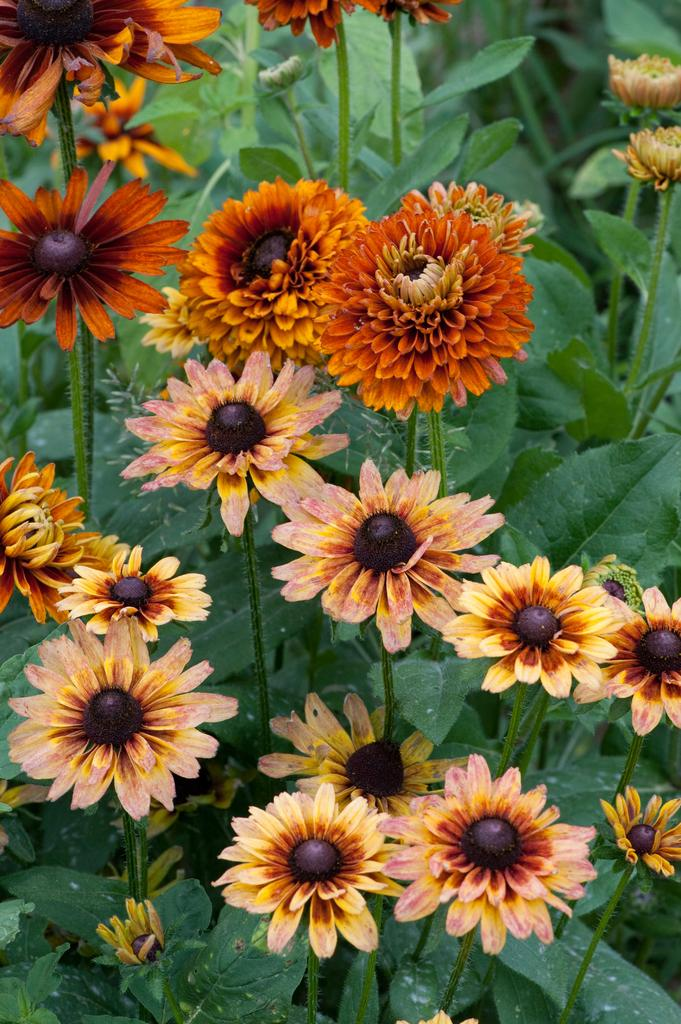What is the main subject of the image? The main subject of the image is a group of flowers. Can you describe the background of the image? There are leaves visible in the background of the image. How many crates are stacked next to the flowers in the image? There are no crates present in the image; it only features a group of flowers and leaves in the background. 